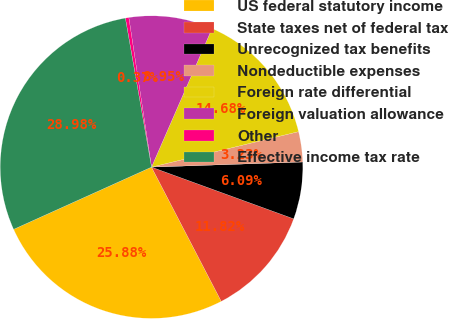Convert chart. <chart><loc_0><loc_0><loc_500><loc_500><pie_chart><fcel>US federal statutory income<fcel>State taxes net of federal tax<fcel>Unrecognized tax benefits<fcel>Nondeductible expenses<fcel>Foreign rate differential<fcel>Foreign valuation allowance<fcel>Other<fcel>Effective income tax rate<nl><fcel>25.88%<fcel>11.82%<fcel>6.09%<fcel>3.23%<fcel>14.68%<fcel>8.95%<fcel>0.37%<fcel>28.98%<nl></chart> 